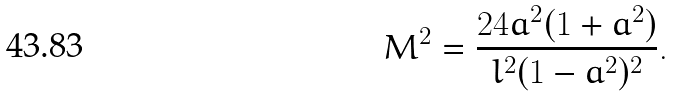Convert formula to latex. <formula><loc_0><loc_0><loc_500><loc_500>M ^ { 2 } = \frac { 2 4 a ^ { 2 } ( 1 + a ^ { 2 } ) } { l ^ { 2 } ( 1 - a ^ { 2 } ) ^ { 2 } } .</formula> 